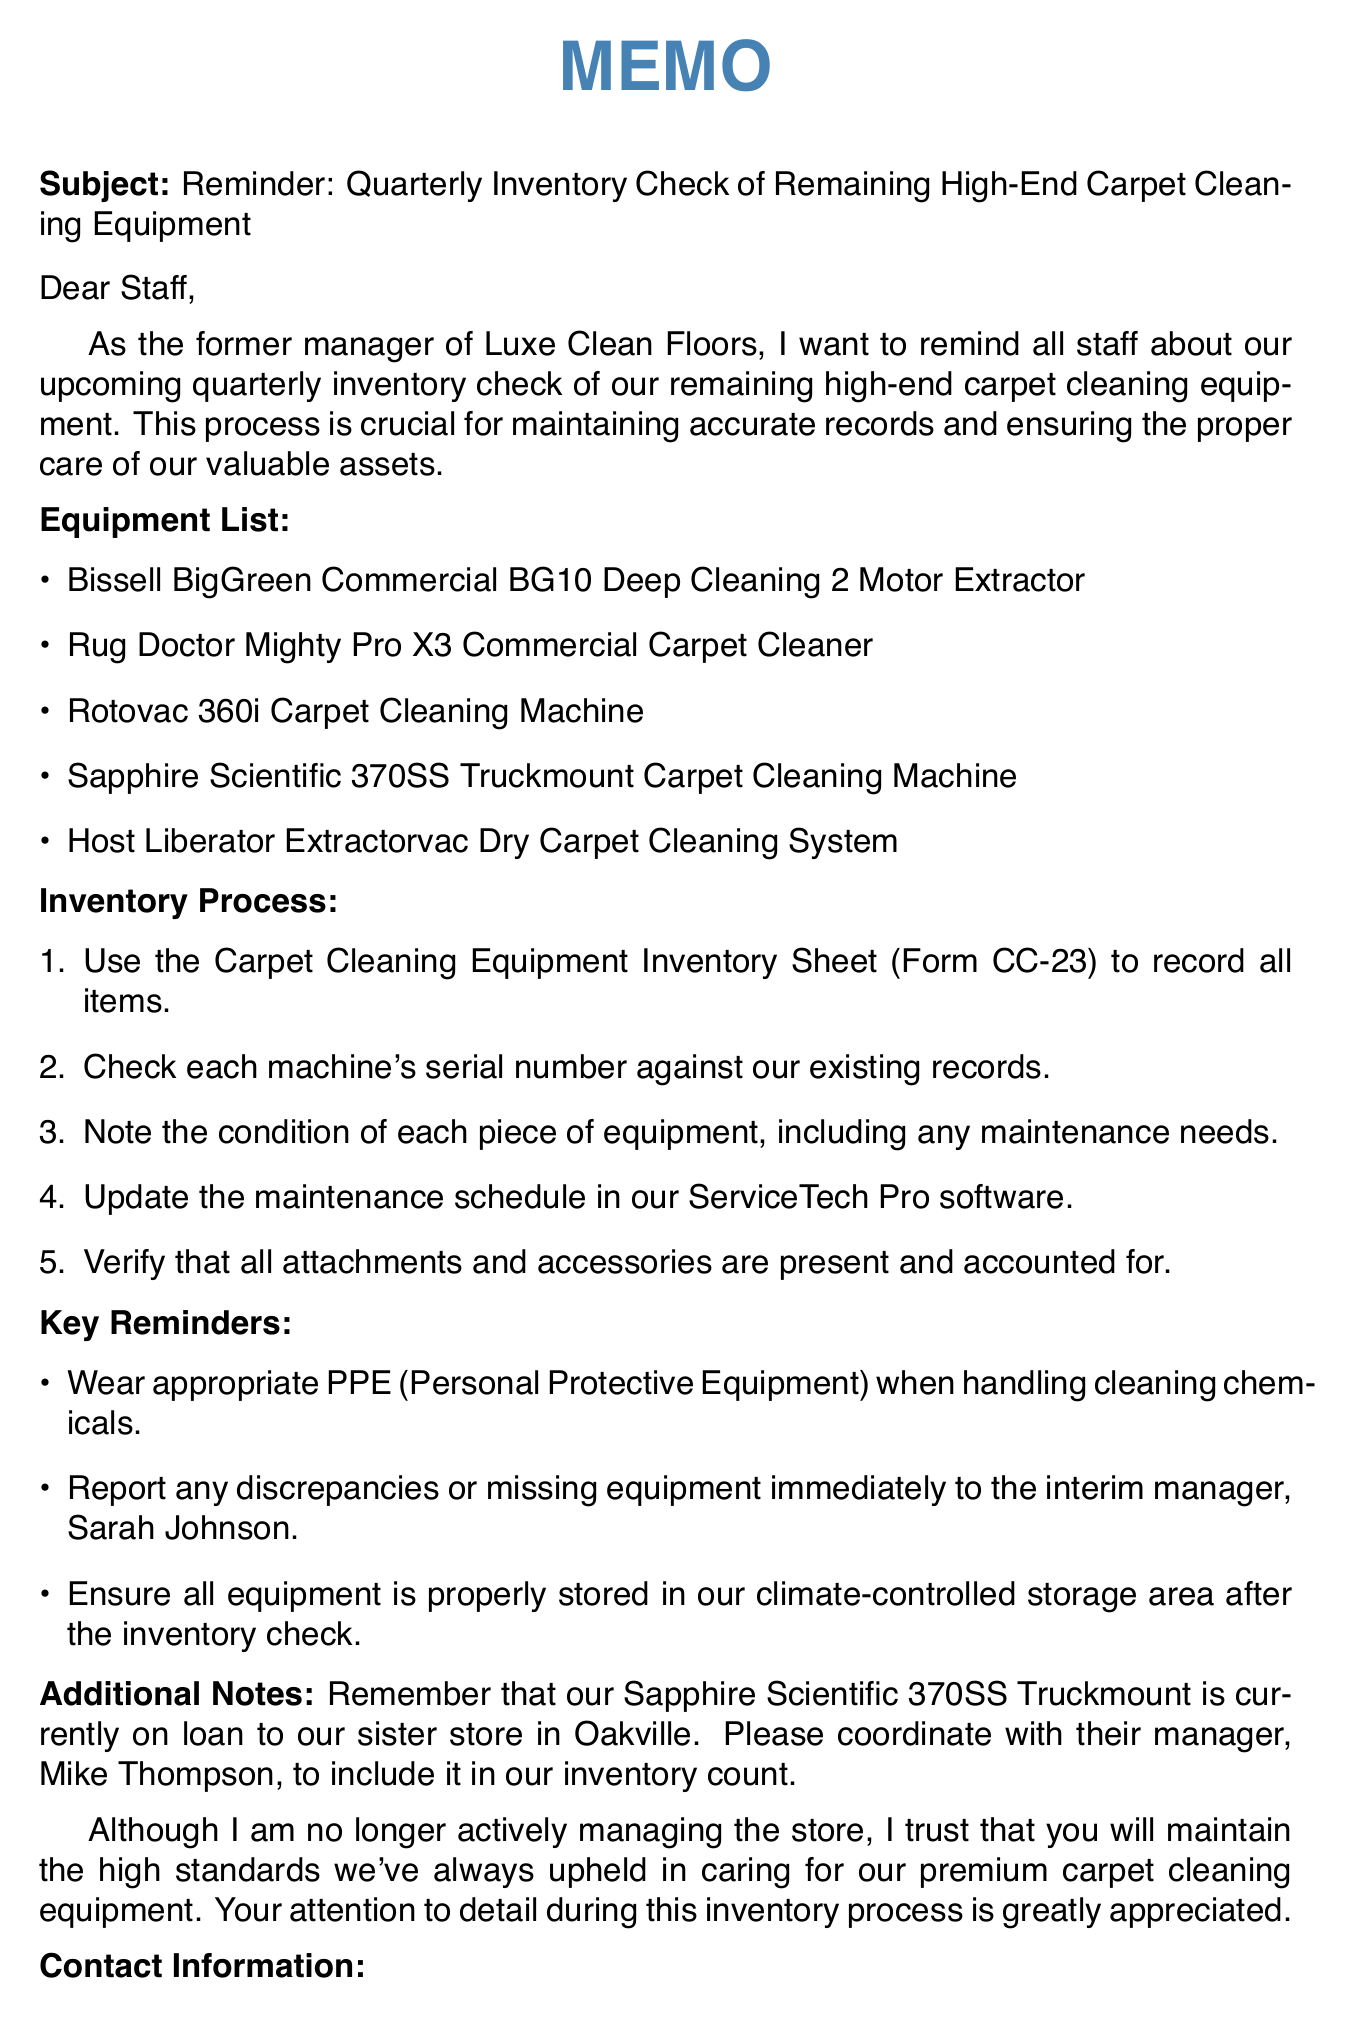what is the subject of the memo? The subject of the memo states the purpose of the communication, which is a reminder for an upcoming inventory check.
Answer: Reminder: Quarterly Inventory Check of Remaining High-End Carpet Cleaning Equipment who should be contacted for discrepancies in the inventory? The memo specifies who to contact in case of discrepancies, providing clarity on where to report issues.
Answer: Sarah Johnson what is the deadline for the inventory check? The memo provides a specific date by which the inventory check needs to be completed.
Answer: Friday, June 30, 2023 how many pieces of high-end carpet cleaning equipment are listed? The number of items in the equipment list indicates the scale of the inventory check required.
Answer: Five what type of PPE should be worn? The memo includes a reminder about safety measures regarding cleaning chemicals, showing the importance of safety.
Answer: Appropriate PPE (Personal Protective Equipment) which carpet cleaning machine is currently on loan? The additional notes mention a specific piece of equipment that is not at the store, highlighting its status.
Answer: Sapphire Scientific 370SS Truckmount Carpet Cleaning Machine what document should be used to record the inventory? The memo outlines the specific form to use for maintaining inventory records, which is essential for the process.
Answer: Carpet Cleaning Equipment Inventory Sheet (Form CC-23) who is the temporary manager overseeing the inventory process? The contact information section provides clarity on who is responsible for managing inventory-related queries during this period.
Answer: Sarah Johnson 